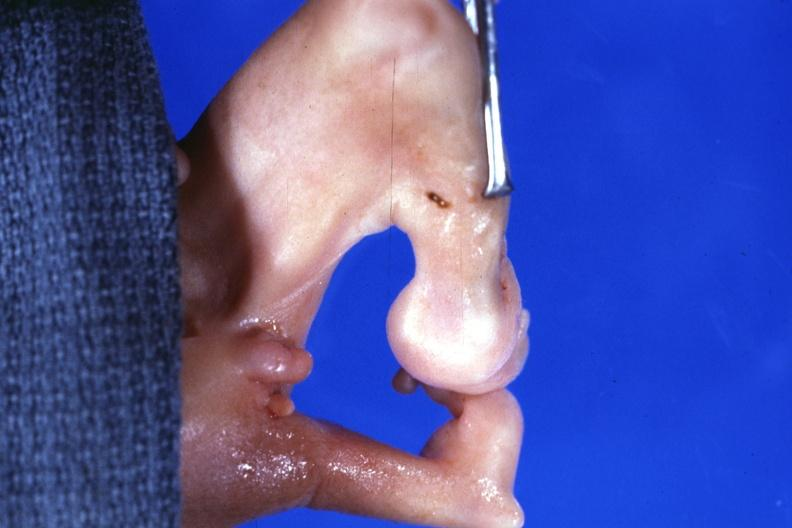s natural color present?
Answer the question using a single word or phrase. No 